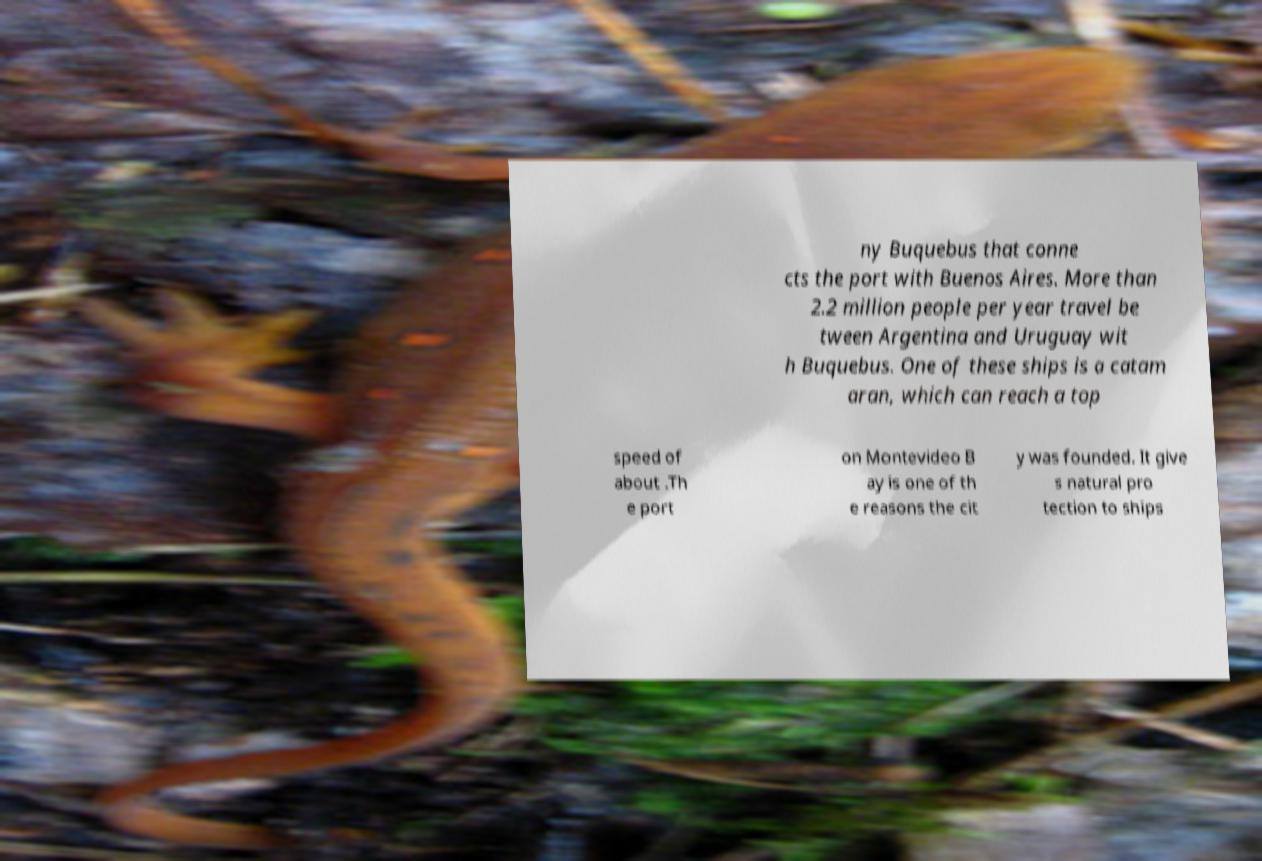I need the written content from this picture converted into text. Can you do that? ny Buquebus that conne cts the port with Buenos Aires. More than 2.2 million people per year travel be tween Argentina and Uruguay wit h Buquebus. One of these ships is a catam aran, which can reach a top speed of about .Th e port on Montevideo B ay is one of th e reasons the cit y was founded. It give s natural pro tection to ships 